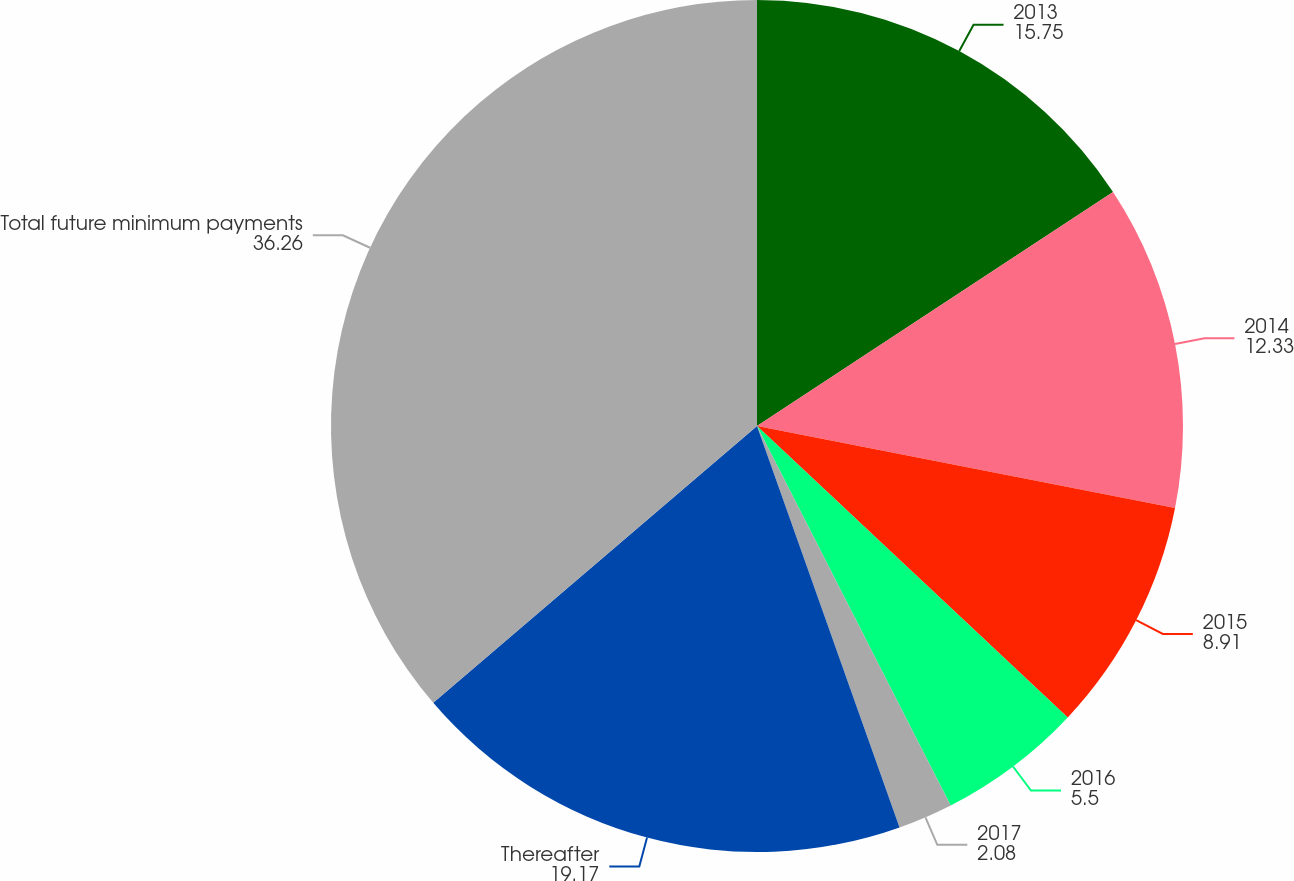<chart> <loc_0><loc_0><loc_500><loc_500><pie_chart><fcel>2013<fcel>2014<fcel>2015<fcel>2016<fcel>2017<fcel>Thereafter<fcel>Total future minimum payments<nl><fcel>15.75%<fcel>12.33%<fcel>8.91%<fcel>5.5%<fcel>2.08%<fcel>19.17%<fcel>36.26%<nl></chart> 